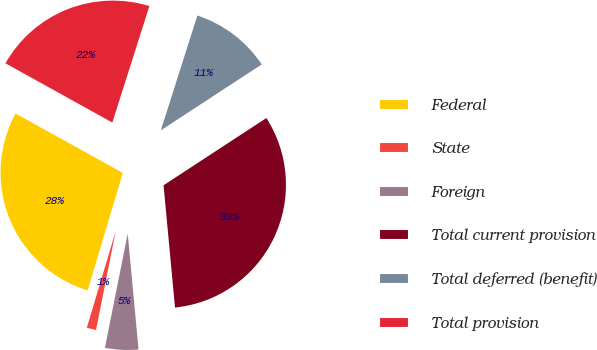<chart> <loc_0><loc_0><loc_500><loc_500><pie_chart><fcel>Federal<fcel>State<fcel>Foreign<fcel>Total current provision<fcel>Total deferred (benefit)<fcel>Total provision<nl><fcel>28.43%<fcel>1.49%<fcel>4.62%<fcel>32.73%<fcel>10.88%<fcel>21.85%<nl></chart> 